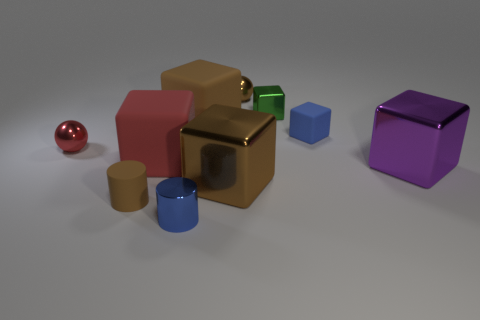How many objects in total can be seen? Upon inspection, a total of seven objects can be identified in the image. Are all of these objects geometric shapes? Yes, each object exhibits a distinct geometric shape, from the spherical ball to the various polyhedral blocks and cylindrical shapes. 